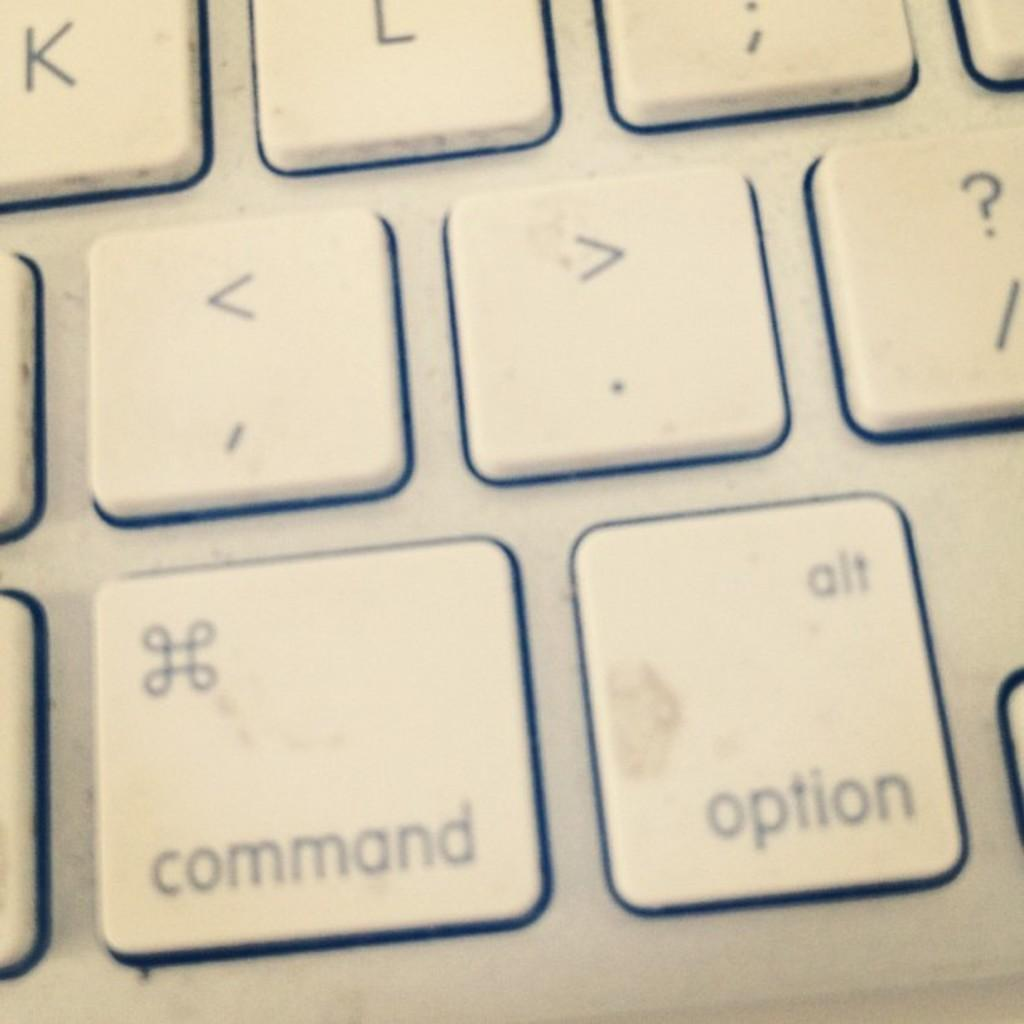<image>
Render a clear and concise summary of the photo. An image showing multiple keys on a keyboard, including the key labled "option". 